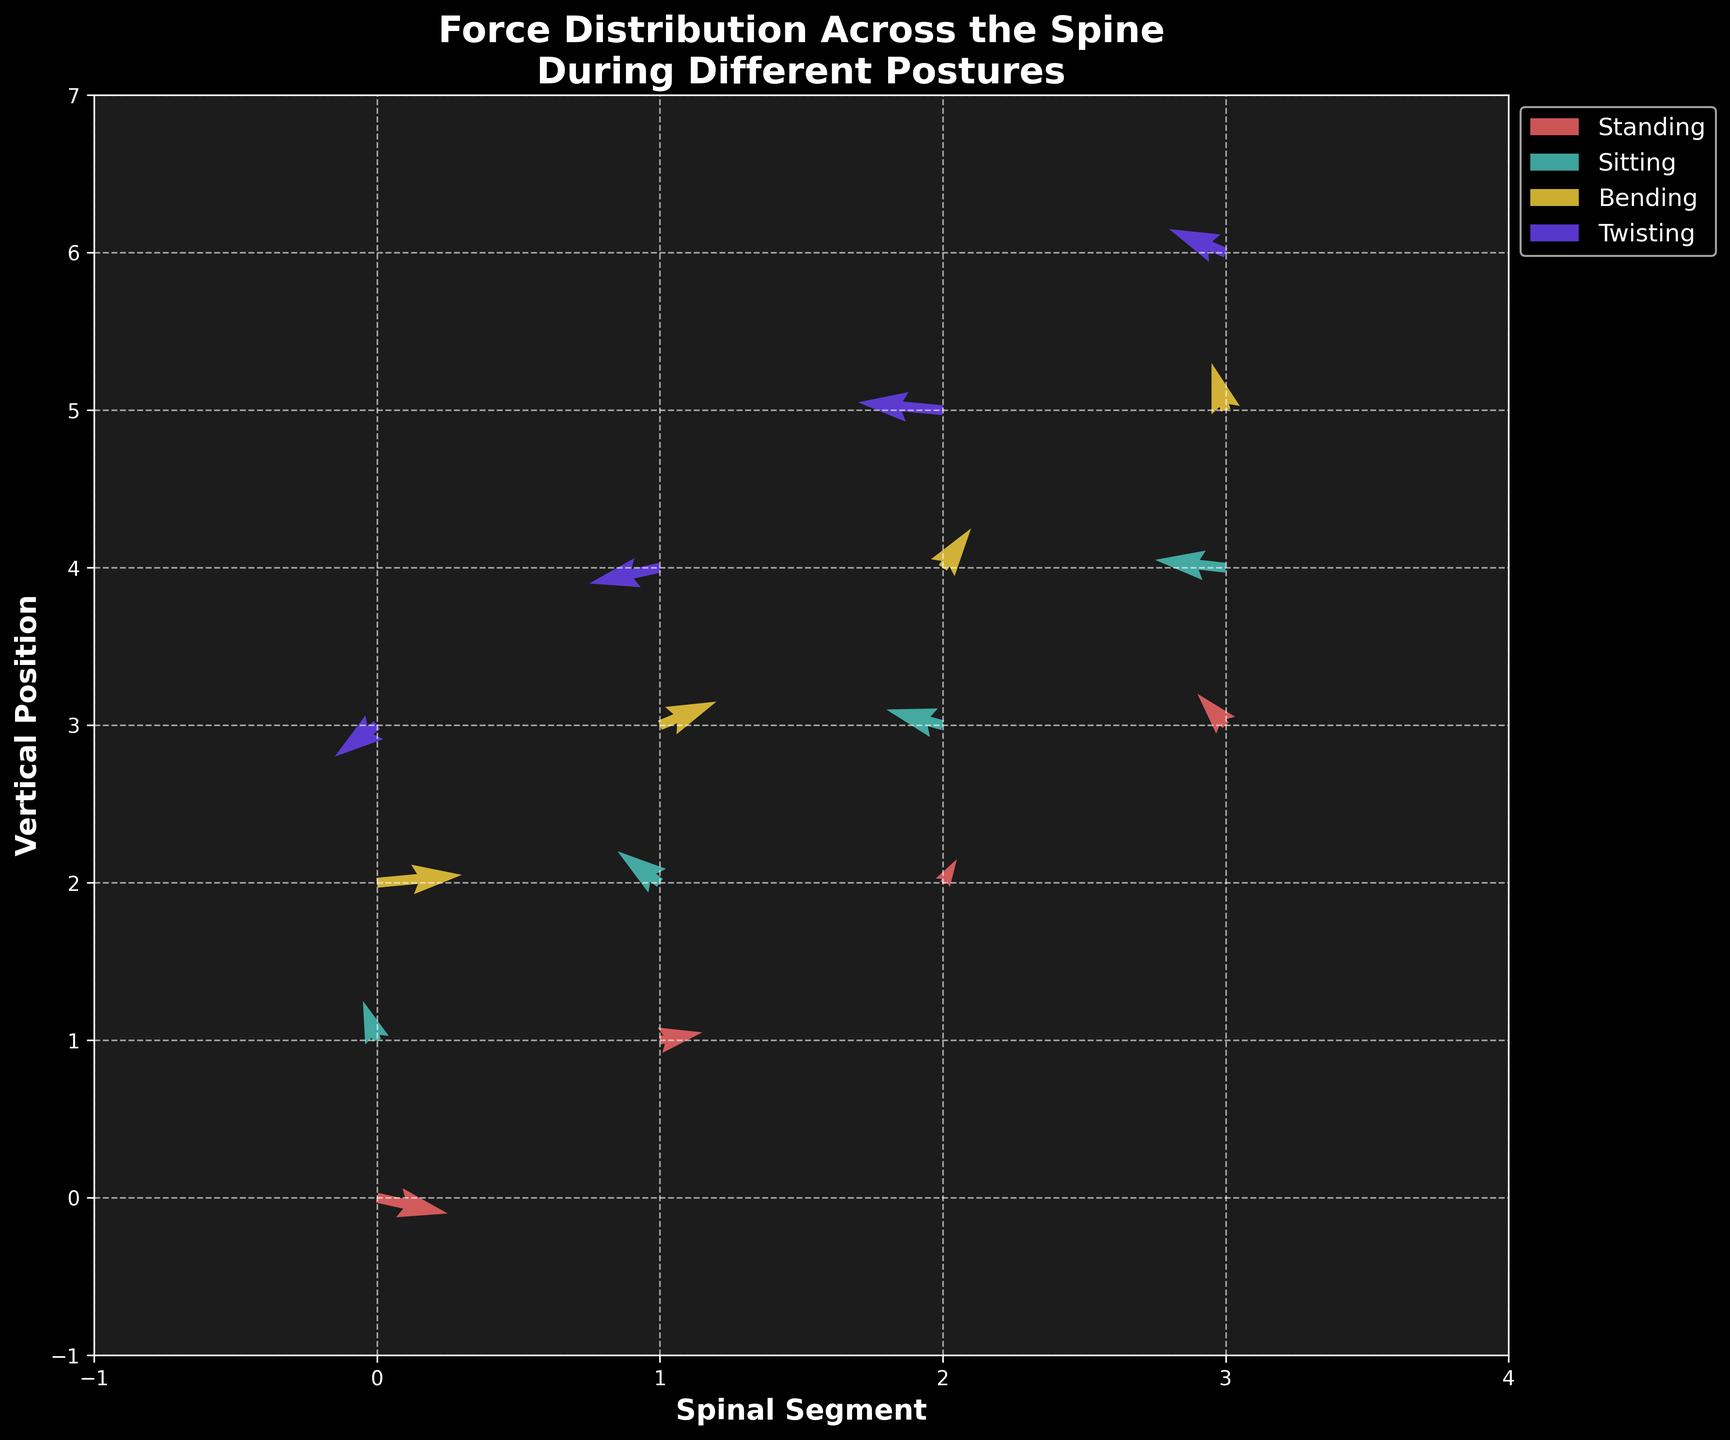what is the title of the figure? The title of the figure is prominently displayed at the top and usually summarizes what the plot is about. In this case, the title is "Force Distribution Across the Spine During Different Postures".
Answer: Force Distribution Across the Spine During Different Postures How many different postures are represented in the figure? By looking at the legend on the right side of the figure, we can see different color labels that correspond to each posture category. There are four different postures listed: Standing, Sitting, Bending, and Twisting.
Answer: Four Which posture shows the largest force in the horizontal direction? By examining the direction and length of the arrows (quivers) in the horizontal axis (U values) for each posture, the posture with the longest arrows in the horizontal direction can be identified. Here, Bending posture has an arrow with U=0.6 at (0,2) which is the largest horizontal force.
Answer: Bending In which posture does the spine segment at (X=2,Y=3) experience a force directed upwards? From the quiver plot, we look for an arrow pointing upwards at coordinates (2,3). This position refers to the Sitting posture, where there's an arrow with U = -0.4 and V = 0.2. Since V is positive, the force is directed upwards.
Answer: Sitting Compare the directions of the force vectors at (X=3,Y=3) for Standing and (X=0,Y=1) for Sitting? For Standing at (3,3), the force vector (U=-0.2, V=0.4) is pointing left and upwards. For Sitting at (0,1), the force vector (U=-0.1, V=0.5) is also pointing left and upwards. Both vectors point in the same general direction.
Answer: Both vectors point left and upwards Which posture involves the most negative force in the horizontal direction? The most negative force in the horizontal direction is represented by the longest arrow pointing left. Twisting at (1,4) has U = -0.5 which is the most negative value among the data provided.
Answer: Twisting What is the color used to represent the Sitting posture? The figure has a legend that assigns colors to each posture; by referring to the legend, we find that the color representing Sitting is light green.
Answer: Light green Is the force vector at (X=1,Y=3) in Bending directed more vertically or horizontally? The force vector at (1,3) for Bending has U=0.4 and V=0.3. Since U is greater than V, the vector is directed more horizontally.
Answer: Horizontally Which posture shows the largest overall force vector? The overall force vector includes both horizontal (U) and vertical (V) components and can be found using the Pythagorean theorem: sqrt(U^2 + V^2). In the Bending posture, vector at (0,2) with U = 0.6 and V = 0.1 gives sqrt(0.6^2 + 0.1^2) = approximately 0.608. We look at all postures to find the largest magnitude, which is indeed this value.
Answer: Bending What are the axes labels in the figure? The axes labels can be found written next to each axis. The x-axis is labeled 'Spinal Segment' and the y-axis is labeled 'Vertical Position'.
Answer: Spinal Segment and Vertical Position 